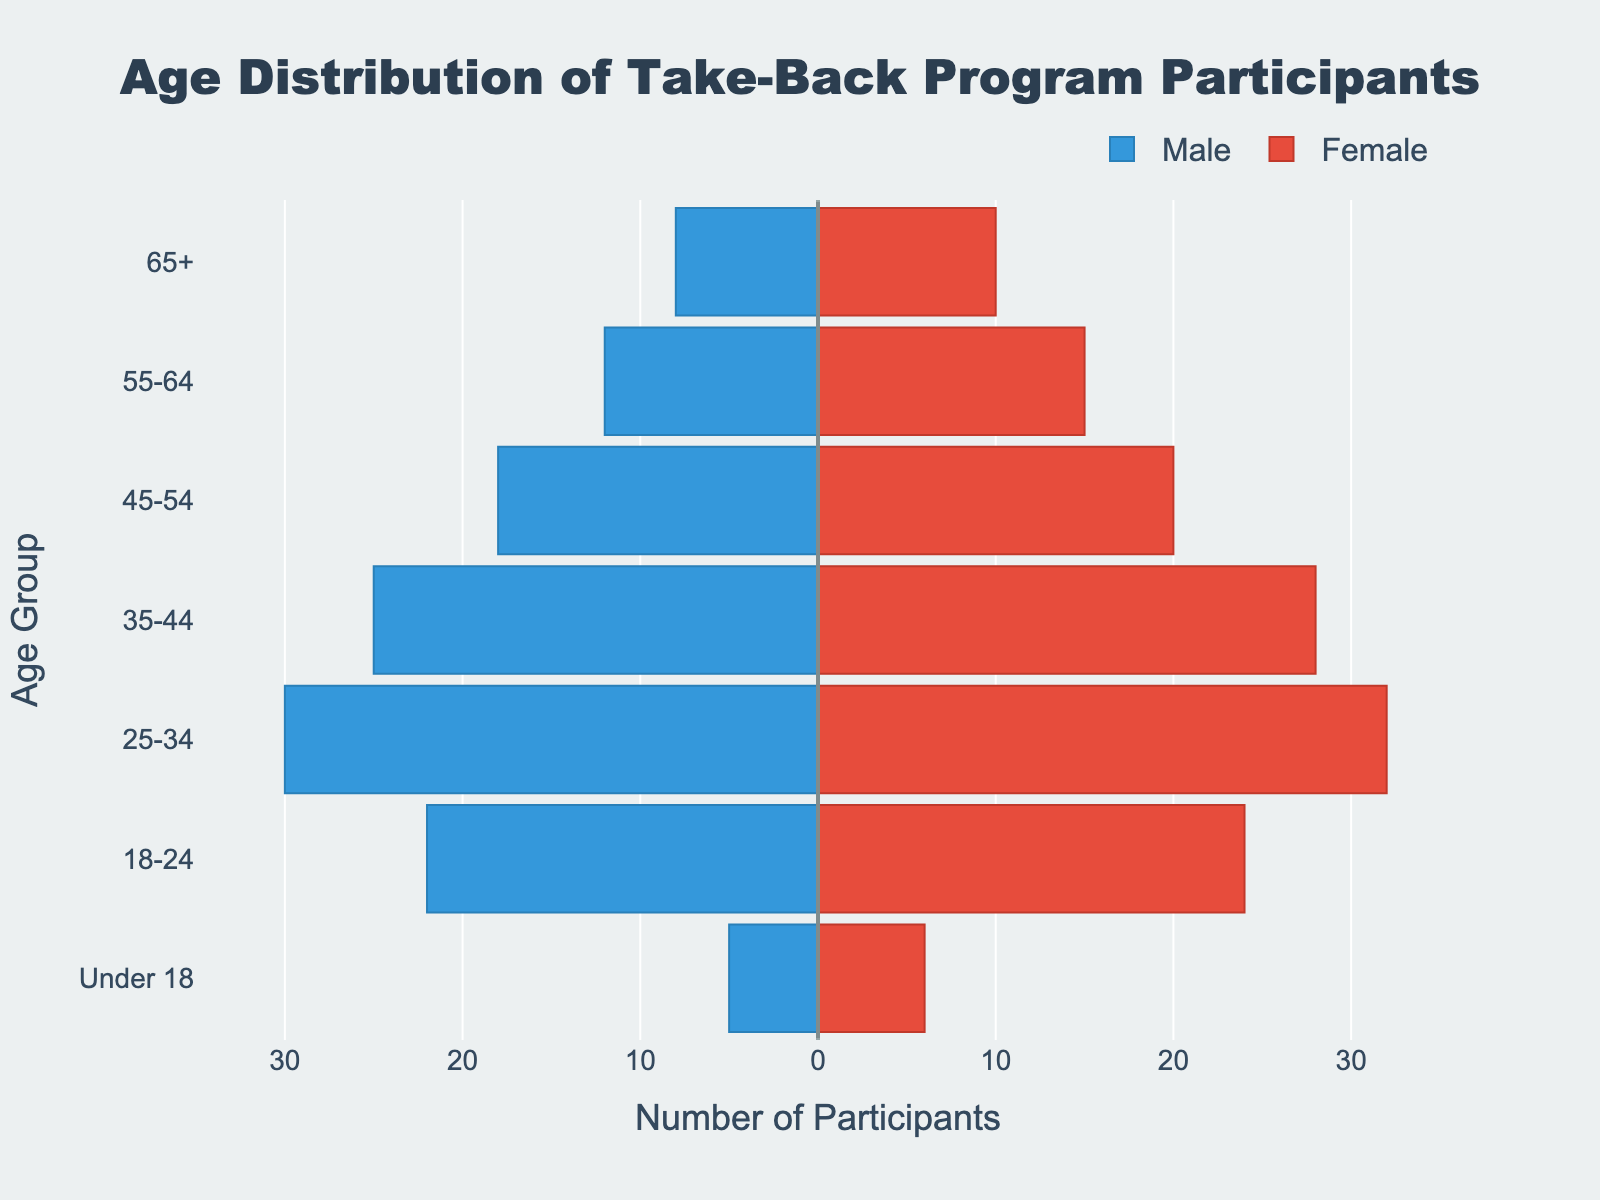Which age group has the highest number of female participants? By looking at the length of the bars on the right side of the pyramid, the 25-34 age group has the longest bar among females.
Answer: 25-34 Which age group has more male participants compared to female participants? By comparing the lengths of the bars on the left and right sides of the pyramid for each age group, no age group has more males than females as the female bars are always longer.
Answer: None What is the total number of participants in the 35-44 age group? For the 35-44 age group, add the number of male participants (25) to the number of female participants (28).
Answer: 53 How does the number of participants under 18 compare to those aged 65+? Compare the sum of male and female participants for both age groups: Under 18 = 5 (M) + 6 (F) = 11; 65+ = 8 (M) + 10 (F) = 18.
Answer: Fewer in Under 18 Which age group has a more balanced gender distribution? By comparing the lengths of male and female bars for each age group, the 18-24 age group has the most balanced distribution with 22 males and 24 females.
Answer: 18-24 In which age group is the gender disparity the largest? Compare the difference in participant numbers between male and female for each age group: for 25-34 it is 32 (F) - 30 (M) = 2, for 55-64 it is 15 (F) - 12 (M) = 3, etc. The 35-44 age group has the largest disparity with 28 (F) - 25 (M) = 3.
Answer: 35-44 What is the median number of participants for all age groups? List all the participant numbers for each age group in ascending order: 11, 18, 38, 45, 50, 63, 65. The median is the middle value of this sorted list.
Answer: 45 How many total male participants are there in the take-back program? Summing up the male participants across all age groups: 8 + 12 + 18 + 25 + 30 + 22 + 5 = 120.
Answer: 120 What's the difference in the number of participants between the 25-34 age group and the 45-54 age group? Calculate the total participants for each group and find the difference: 25-34 = 30 (M) + 32 (F) = 62, 45-54 = 18 (M) + 20 (F) = 38; Difference = 62 - 38.
Answer: 24 Which age group has the fewest participants overall? By summing both male and female for each age group and comparing, the Under 18 age group has the fewest with a total of 11 participants.
Answer: Under 18 